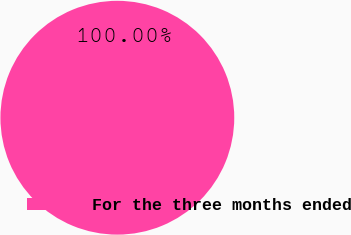<chart> <loc_0><loc_0><loc_500><loc_500><pie_chart><fcel>For the three months ended<nl><fcel>100.0%<nl></chart> 